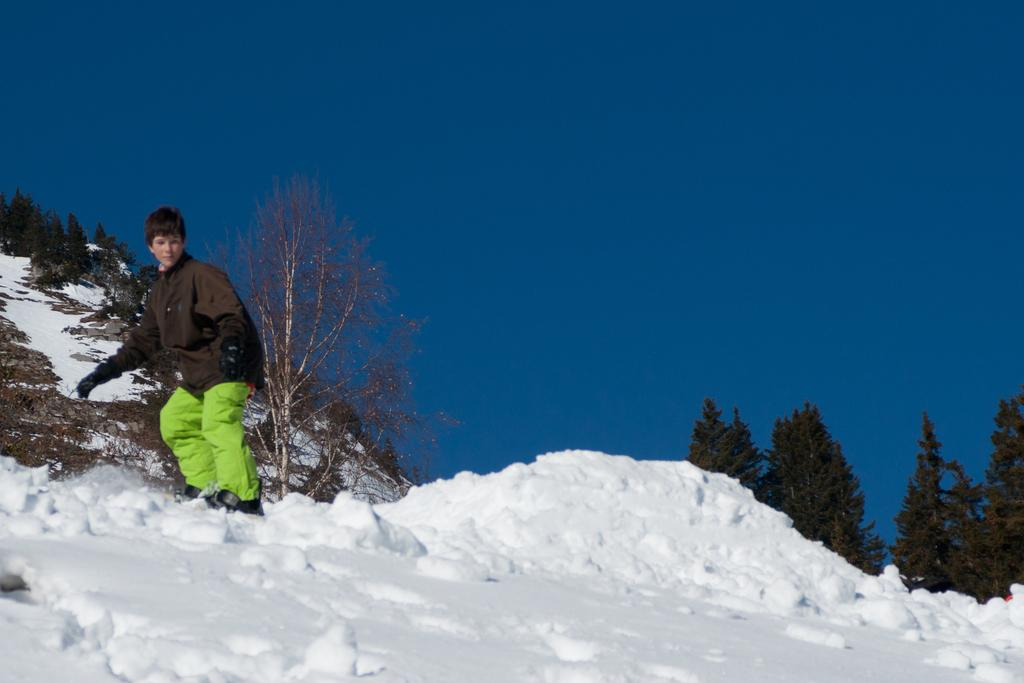What is covering the ground in the foreground of the image? There is snow in the foreground of the image. What is the person on the left side of the image doing? There is a person skating on the left side of the image. What can be seen in the background towards the left side of the image? There are trees and a hill in the background towards the left side of the image. What is present on the right side of the image? There are trees on the right side of the image. How would you describe the sky in the image? The sky is clear in the image. What type of quince is being used to sweeten the honey in the image? There is no quince or honey present in the image; it features a person skating on snow with trees and a hill in the background. What color is the dress worn by the person skating in the image? There is no dress visible in the image; the person is wearing skating attire appropriate for snowy conditions. 